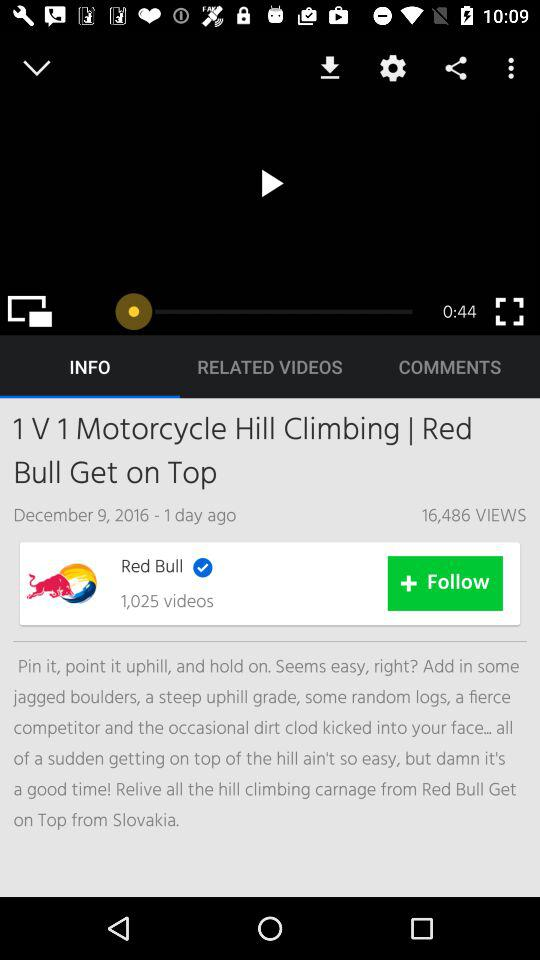How many more views does the video have than comments?
Answer the question using a single word or phrase. 16486 